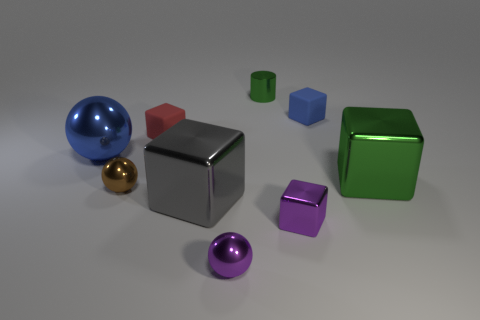What number of shiny things are there? There are seven shiny objects, each with a distinct color and shape. These include a blue sphere, a red cube, a smaller green cube, a large silver cube at the center, a golden sphere, a smaller purple cube, and a pink sphere. Besides their reflective surfaces, the arrangement and differing sizes present a visually interesting composition. 